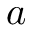Convert formula to latex. <formula><loc_0><loc_0><loc_500><loc_500>a</formula> 